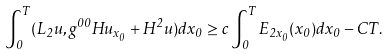Convert formula to latex. <formula><loc_0><loc_0><loc_500><loc_500>\int _ { 0 } ^ { T } ( L _ { 2 } u , g ^ { 0 0 } H u _ { x _ { 0 } } + H ^ { 2 } u ) d x _ { 0 } \geq c \int _ { 0 } ^ { T } E _ { 2 x _ { 0 } } ( x _ { 0 } ) d x _ { 0 } - C T .</formula> 